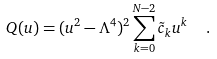Convert formula to latex. <formula><loc_0><loc_0><loc_500><loc_500>Q ( u ) = ( u ^ { 2 } - \Lambda ^ { 4 } ) ^ { 2 } \sum _ { k = 0 } ^ { N - 2 } \tilde { c } _ { k } u ^ { k } \ \ .</formula> 